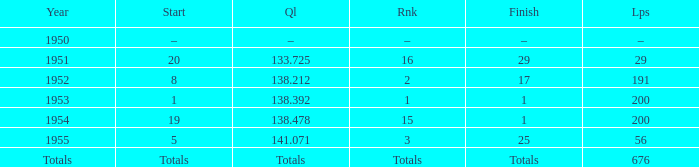How many laps was qualifier of 138.212? 191.0. 